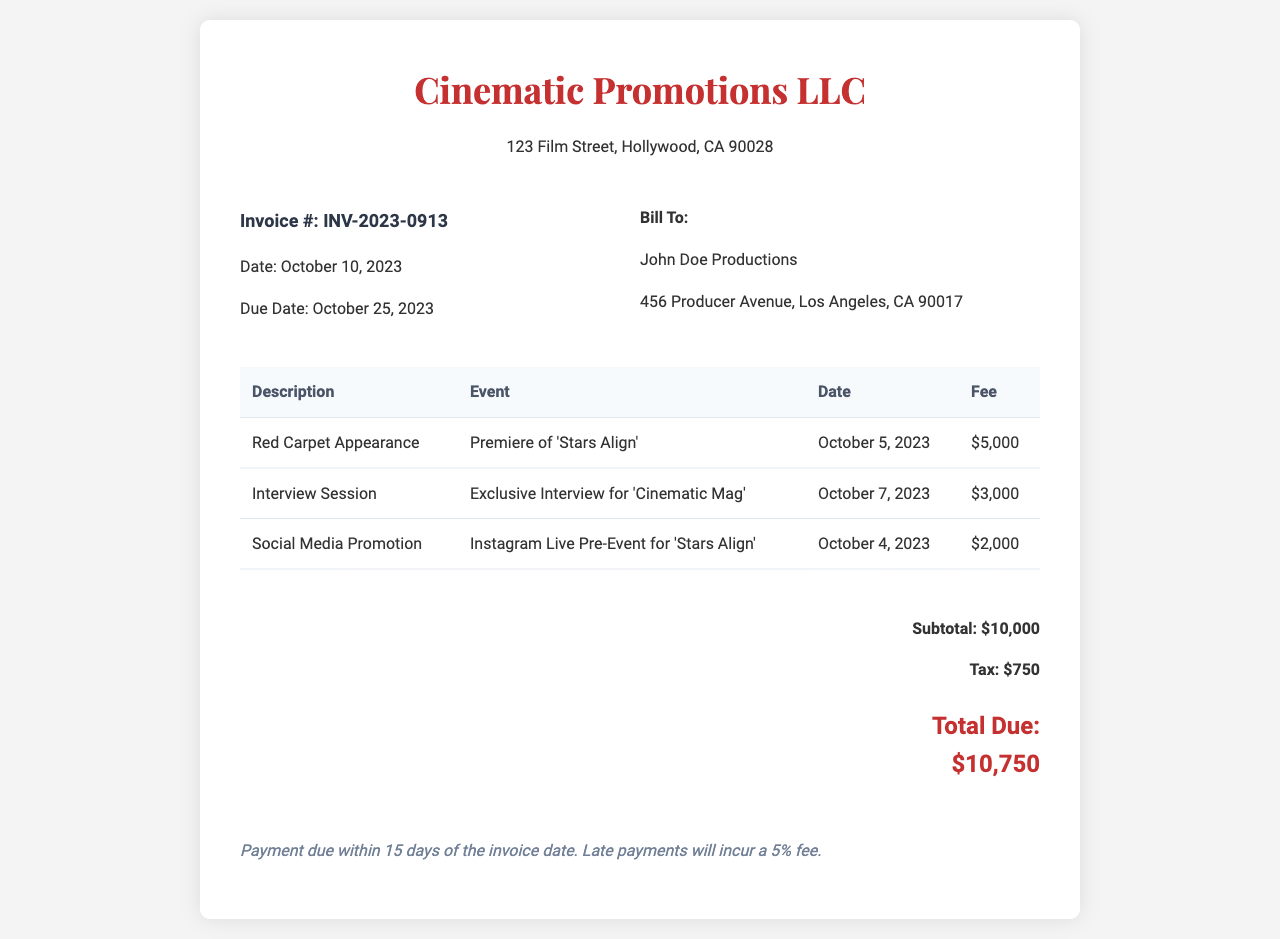what is the invoice number? The invoice number is explicitly stated in the document as INV-2023-0913.
Answer: INV-2023-0913 what is the due date? The due date for payment according to the invoice is specified as October 25, 2023.
Answer: October 25, 2023 who is the invoice billed to? The document lists the recipient of the invoice as John Doe Productions.
Answer: John Doe Productions what is the total due amount? The total amount due, as calculated from the subtotal and tax in the document, is $10,750.
Answer: $10,750 how much is the fee for the Red Carpet Appearance? The fee for the Red Carpet Appearance event is clearly mentioned as $5,000.
Answer: $5,000 what type of invoice is this? This document is an invoice specifically for promotional appearances and events related to film releases.
Answer: Invoice for promotional appearances how many events are listed in the invoice? The document provides details for a total of three events related to film promotions.
Answer: Three what is the tax amount applied? The tax amount specified in the invoice is $750.
Answer: $750 what is the payment term mentioned? The payment term states that payment is due within 15 days of the invoice date.
Answer: 15 days 